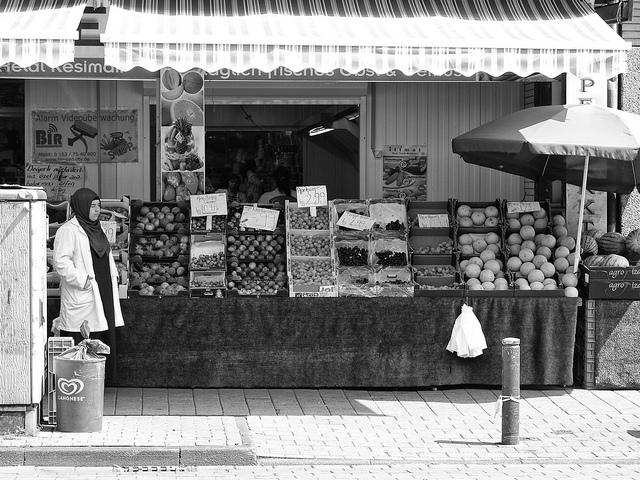The largest fruit shown here is what type of Fruit? grapefruit 